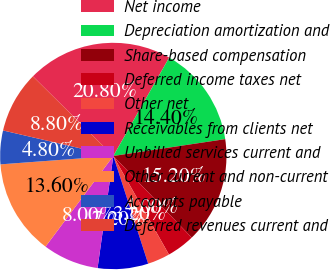<chart> <loc_0><loc_0><loc_500><loc_500><pie_chart><fcel>Net income<fcel>Depreciation amortization and<fcel>Share-based compensation<fcel>Deferred income taxes net<fcel>Other net<fcel>Receivables from clients net<fcel>Unbilled services current and<fcel>Other current and non-current<fcel>Accounts payable<fcel>Deferred revenues current and<nl><fcel>20.8%<fcel>14.4%<fcel>15.2%<fcel>4.0%<fcel>3.2%<fcel>7.2%<fcel>8.0%<fcel>13.6%<fcel>4.8%<fcel>8.8%<nl></chart> 